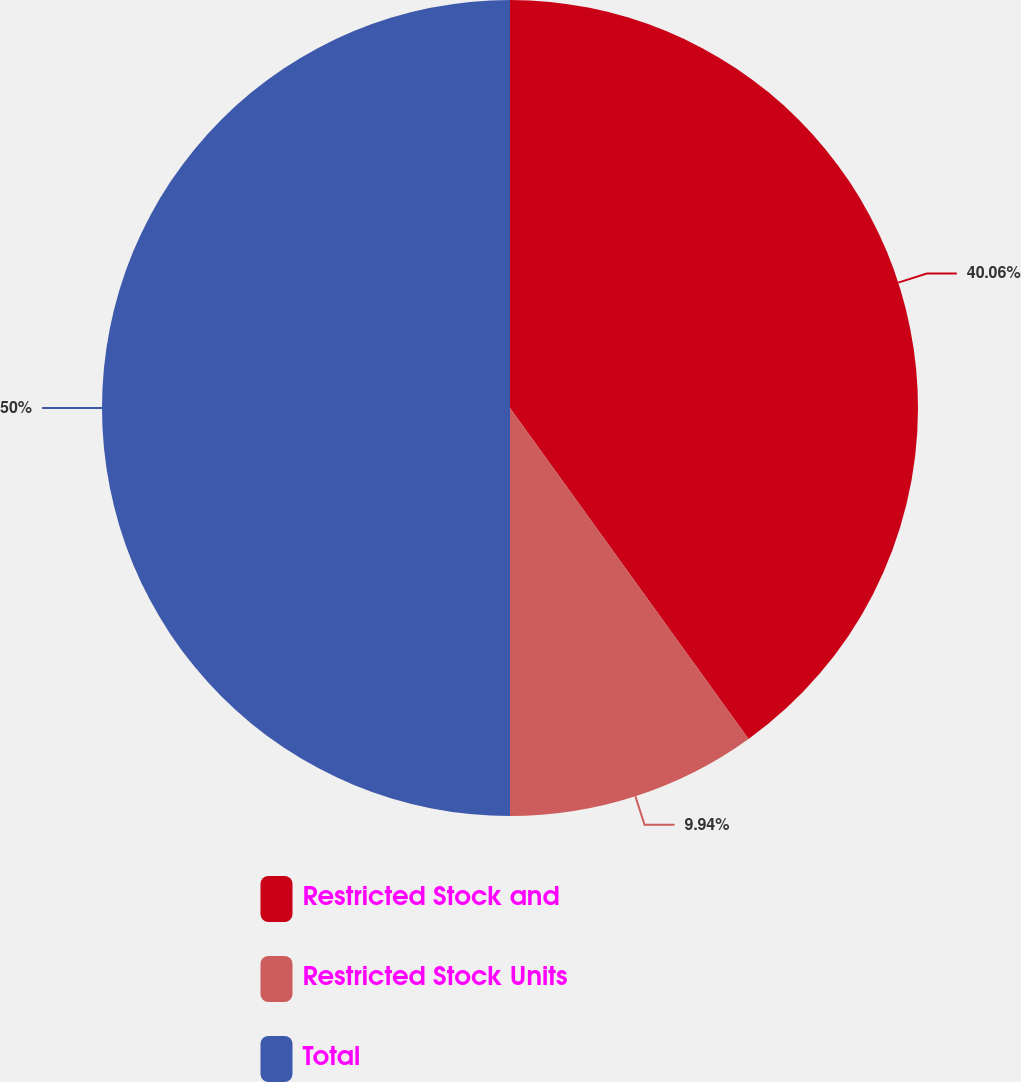Convert chart to OTSL. <chart><loc_0><loc_0><loc_500><loc_500><pie_chart><fcel>Restricted Stock and<fcel>Restricted Stock Units<fcel>Total<nl><fcel>40.06%<fcel>9.94%<fcel>50.0%<nl></chart> 